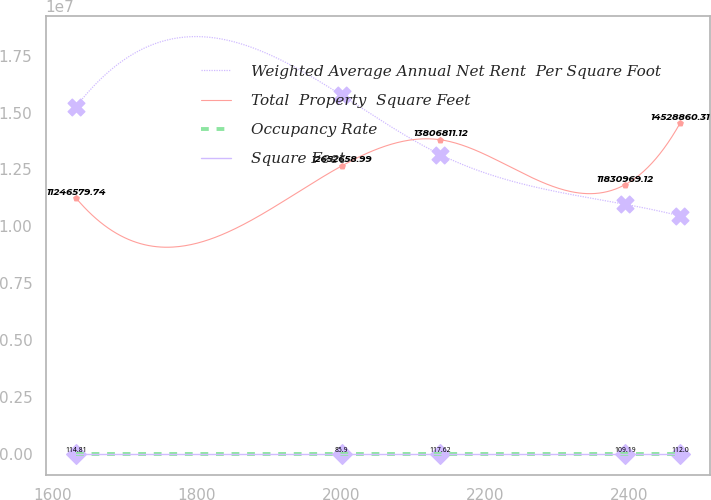Convert chart to OTSL. <chart><loc_0><loc_0><loc_500><loc_500><line_chart><ecel><fcel>Weighted Average Annual Net Rent  Per Square Foot<fcel>Total  Property  Square Feet<fcel>Occupancy Rate<fcel>Square Feet<nl><fcel>1632.46<fcel>1.52582e+07<fcel>1.12466e+07<fcel>114.81<fcel>20.42<nl><fcel>2001.17<fcel>1.57686e+07<fcel>1.26527e+07<fcel>85.9<fcel>13.81<nl><fcel>2138.4<fcel>1.31553e+07<fcel>1.38068e+07<fcel>117.62<fcel>19.8<nl><fcel>2394.73<fcel>1.09702e+07<fcel>1.1831e+07<fcel>109.19<fcel>14.43<nl><fcel>2471.03<fcel>1.04598e+07<fcel>1.45289e+07<fcel>112<fcel>18.32<nl></chart> 